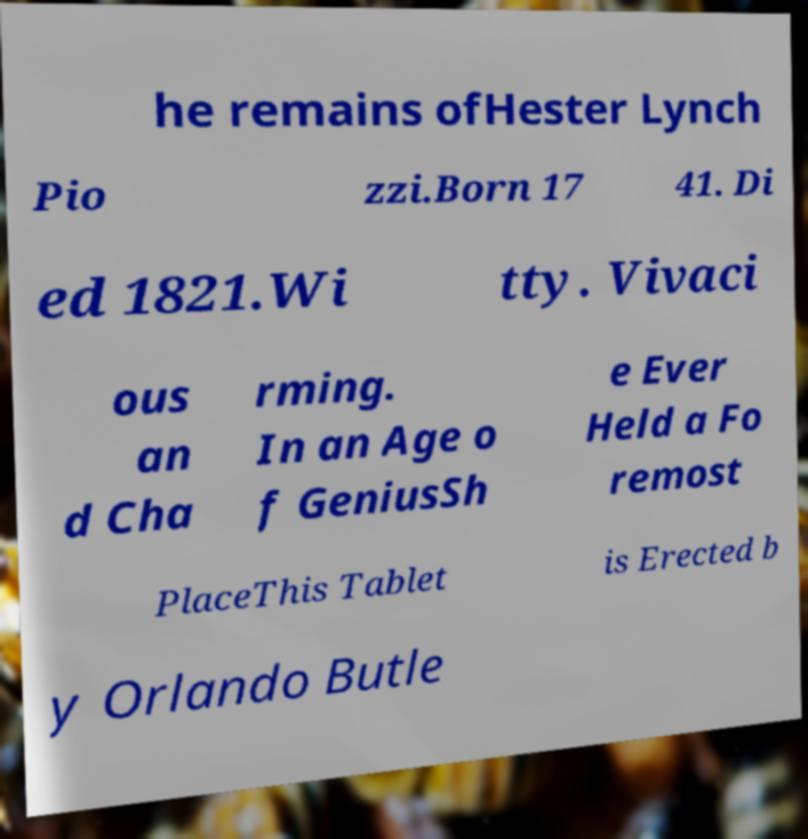Could you extract and type out the text from this image? he remains ofHester Lynch Pio zzi.Born 17 41. Di ed 1821.Wi tty. Vivaci ous an d Cha rming. In an Age o f GeniusSh e Ever Held a Fo remost PlaceThis Tablet is Erected b y Orlando Butle 